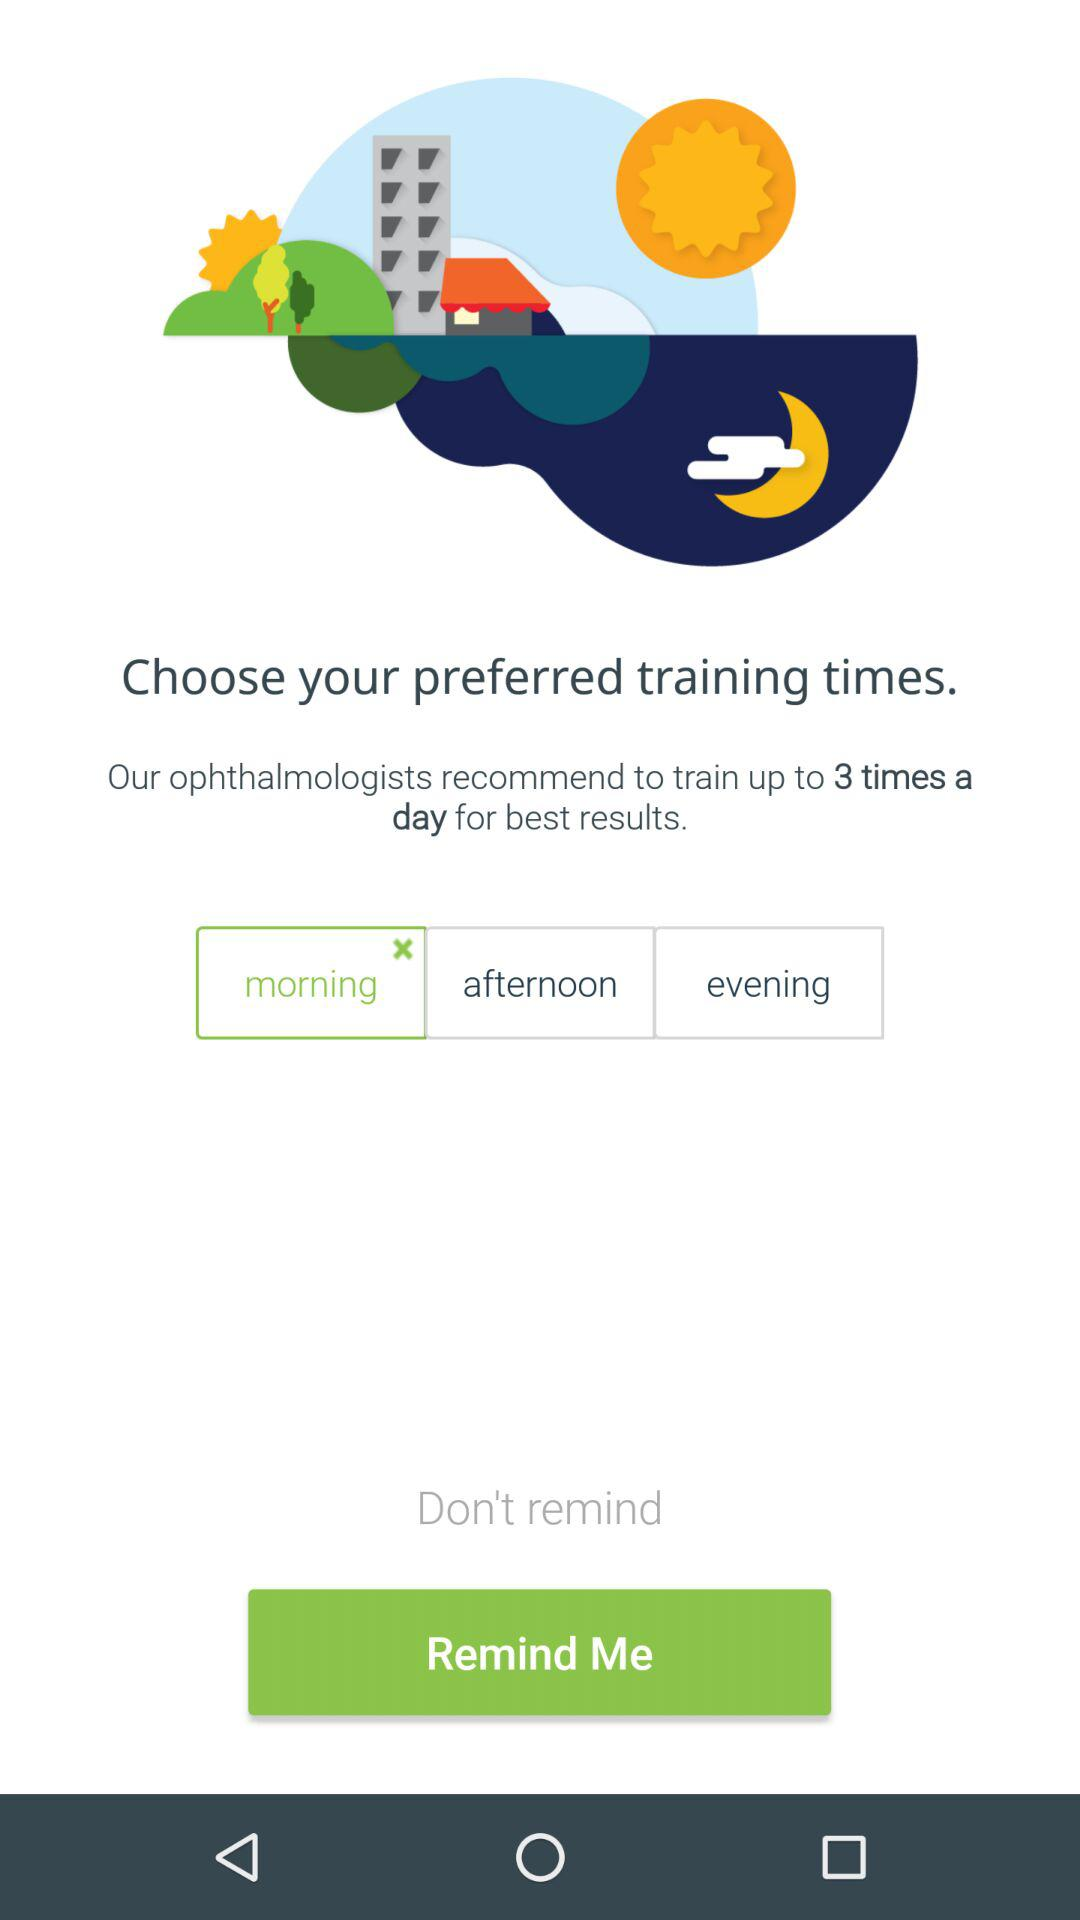What is the preferred time for training? The preferred time is "morning". 